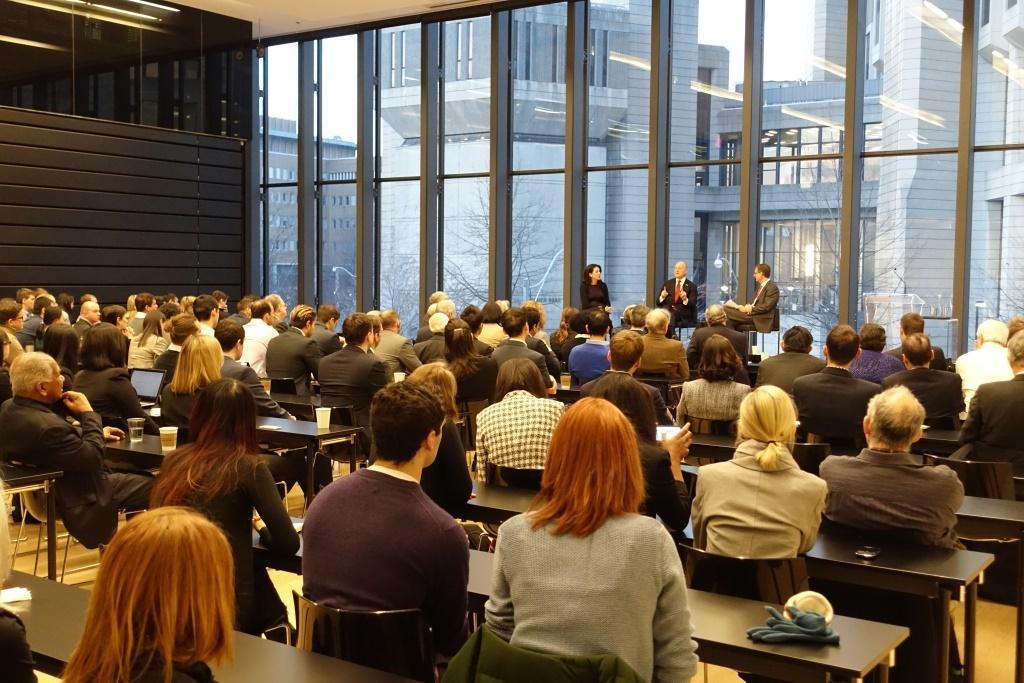In one or two sentences, can you explain what this image depicts? In this picture there are few persons sitting in chairs and there is a table in front of them which has few objects on it and there are three persons sitting in front of them and there is a building in the background. 